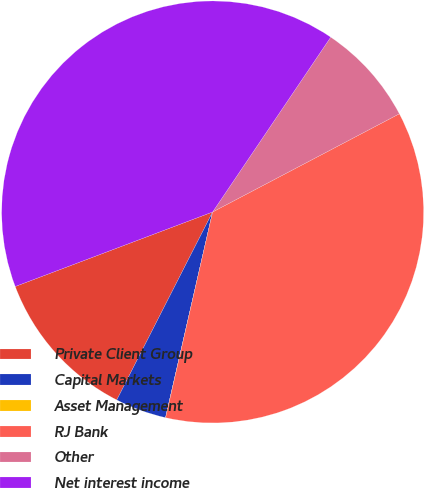Convert chart to OTSL. <chart><loc_0><loc_0><loc_500><loc_500><pie_chart><fcel>Private Client Group<fcel>Capital Markets<fcel>Asset Management<fcel>RJ Bank<fcel>Other<fcel>Net interest income<nl><fcel>11.75%<fcel>3.92%<fcel>0.01%<fcel>36.28%<fcel>7.84%<fcel>40.2%<nl></chart> 